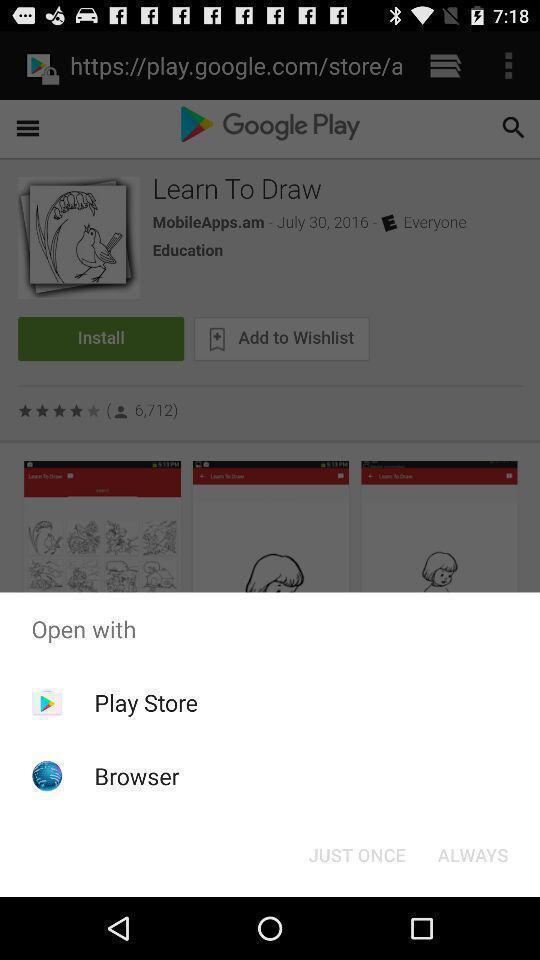Describe this image in words. Pop up showing various apps. 